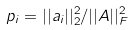<formula> <loc_0><loc_0><loc_500><loc_500>p _ { i } = | | a _ { i } | | _ { 2 } ^ { 2 } / | | A | | _ { F } ^ { 2 }</formula> 